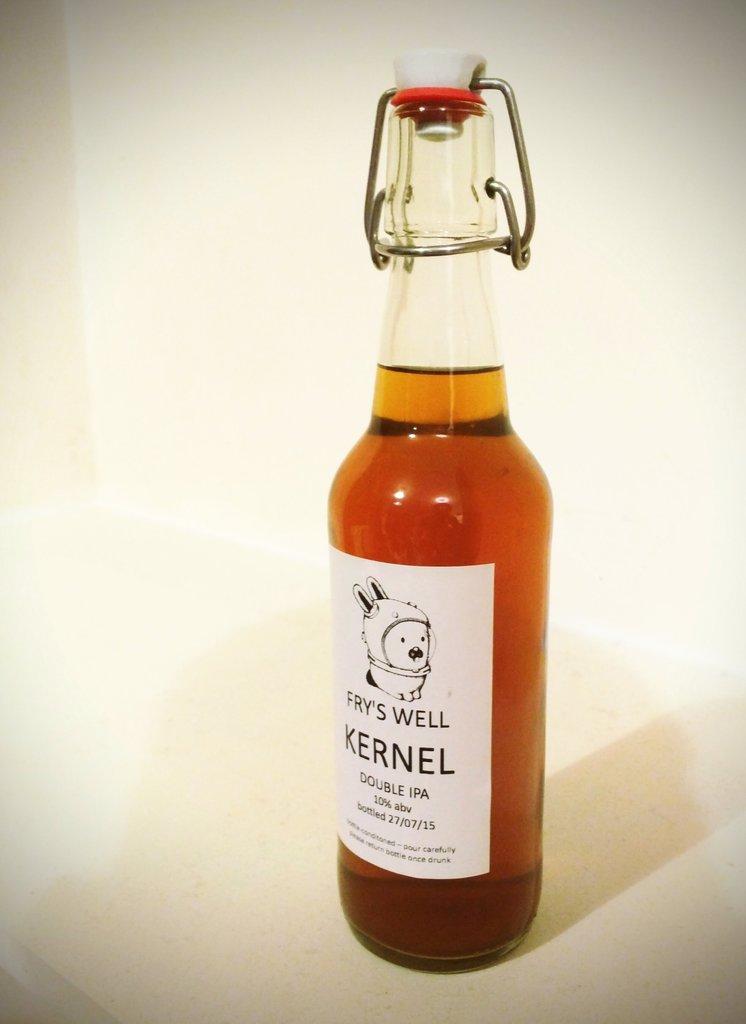What kind of beer is this?
Your response must be concise. Double ipa. When was this bottled?
Your response must be concise. 27/07/15. 